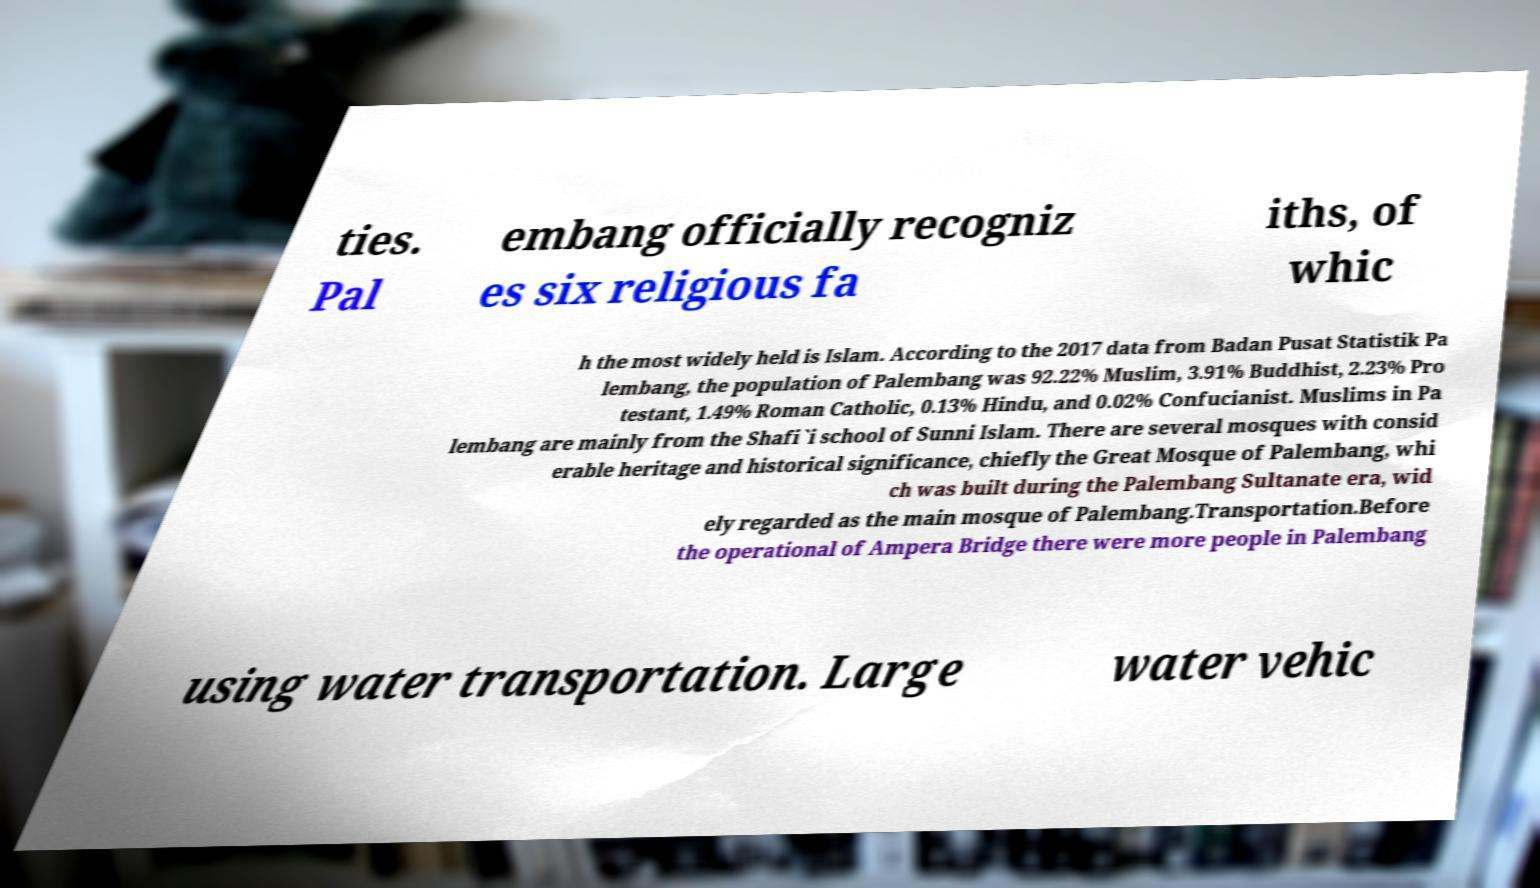Please read and relay the text visible in this image. What does it say? ties. Pal embang officially recogniz es six religious fa iths, of whic h the most widely held is Islam. According to the 2017 data from Badan Pusat Statistik Pa lembang, the population of Palembang was 92.22% Muslim, 3.91% Buddhist, 2.23% Pro testant, 1.49% Roman Catholic, 0.13% Hindu, and 0.02% Confucianist. Muslims in Pa lembang are mainly from the Shafi`i school of Sunni Islam. There are several mosques with consid erable heritage and historical significance, chiefly the Great Mosque of Palembang, whi ch was built during the Palembang Sultanate era, wid ely regarded as the main mosque of Palembang.Transportation.Before the operational of Ampera Bridge there were more people in Palembang using water transportation. Large water vehic 